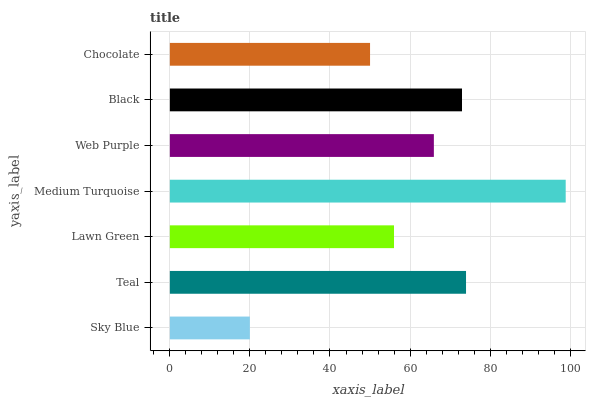Is Sky Blue the minimum?
Answer yes or no. Yes. Is Medium Turquoise the maximum?
Answer yes or no. Yes. Is Teal the minimum?
Answer yes or no. No. Is Teal the maximum?
Answer yes or no. No. Is Teal greater than Sky Blue?
Answer yes or no. Yes. Is Sky Blue less than Teal?
Answer yes or no. Yes. Is Sky Blue greater than Teal?
Answer yes or no. No. Is Teal less than Sky Blue?
Answer yes or no. No. Is Web Purple the high median?
Answer yes or no. Yes. Is Web Purple the low median?
Answer yes or no. Yes. Is Medium Turquoise the high median?
Answer yes or no. No. Is Lawn Green the low median?
Answer yes or no. No. 